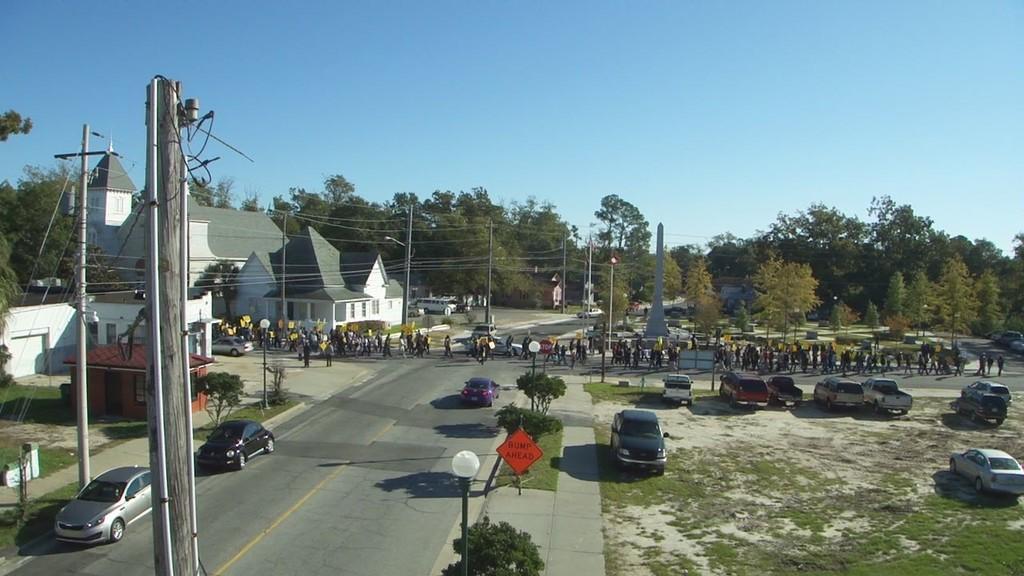Can you describe this image briefly? In this image there are houses, poles, trees, sky, light poles, board, grass and objects. People and vehicles are on the road. 